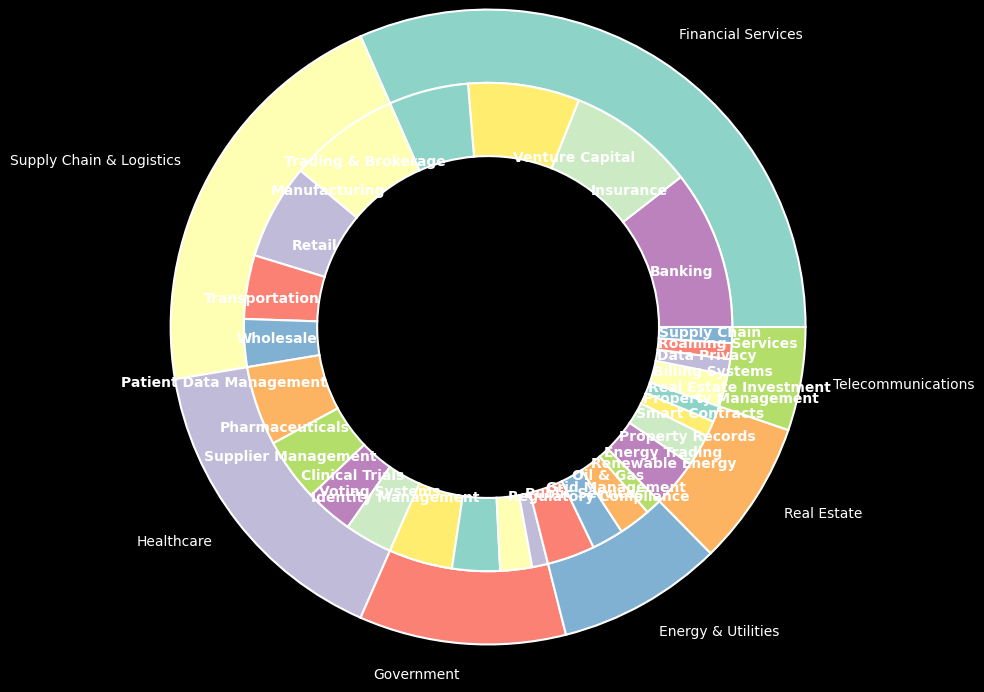Which industry has the largest market share and what percentage is it? The largest Market Share is found by identifying the industry with the widest outer pie slice. From the visual data, Financial Services has the largest market share. The percentage is indicated in the original data and the figure.
Answer: Financial Services, 30% Which industries have a market share of 20% each? By looking at the pie chart, we need to find the slices in the outer ring labeled 20%. The figure and the original data indicate that Supply Chain & Logistics has a 20% market share.
Answer: Supply Chain & Logistics Compare the market share of Healthcare and Government industries. Which one is larger and by how much? From the outer pie, Healthcare is represented by a 15% slice, and Government is by a 10% slice. Subtracting the smaller share from the larger gives us the difference. Thus, 15% - 10% = 5%.
Answer: Healthcare is larger by 5% What is the combined market share of Energy & Utilities and Telecommunications? The market shares for Energy & Utilities and Telecommunications are 8% and 5%, respectively. Adding these percentages together, we get 8% + 5% = 13%.
Answer: 13% Identify the subcategory with the smallest share within the Supply Chain & Logistics industry and mention its share. Within the Supply Chain & Logistics slice, the subcategories’ slices indicate their shares. The smallest subcategory slice is Wholesale, which is marked at 3%.
Answer: Wholesale, 3% How does the share of Banking in Financial Services compare to Grid Management in Energy & Utilities? Banking in Financial Services has a slice of 10%, while Grid Management in Energy & Utilities has a slice of 3%. So, Banking has a higher share.
Answer: Banking (10%) is larger What percentage of the market share do the subcategories of the Healthcare industry collectively contribute? This requires summing the shares of all subcategories under Healthcare: Patient Data Management (5%), Pharmaceuticals (4%), Supplier Management (3%), and Clinical Trials (3%). The total is 5% + 4% + 3% + 3% = 15%.
Answer: 15% Which subcategory in Financial Services has a share equal to the total market share of Real Estate? First, observe the subcategory shares in Financial Services. The subcategory Insurance has 8%, and Real Estate as an industry also has a 7% market share. So, none match exactly, but the closest is Banking with 10%.
Answer: Banking Calculate the total market share of all industries that have less than 10% share individually. Looking at the pie, Real Estate (7%) and Telecommunications (5%) fit the criteria. Summing these: 7% + 5% = 12%.
Answer: 12% 